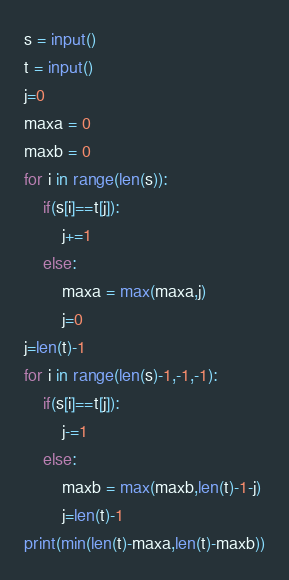Convert code to text. <code><loc_0><loc_0><loc_500><loc_500><_Python_>s = input()
t = input()
j=0
maxa = 0
maxb = 0
for i in range(len(s)):
    if(s[i]==t[j]):
        j+=1
    else:
        maxa = max(maxa,j)
        j=0
j=len(t)-1
for i in range(len(s)-1,-1,-1):
    if(s[i]==t[j]):
        j-=1
    else:
        maxb = max(maxb,len(t)-1-j)
        j=len(t)-1
print(min(len(t)-maxa,len(t)-maxb))</code> 